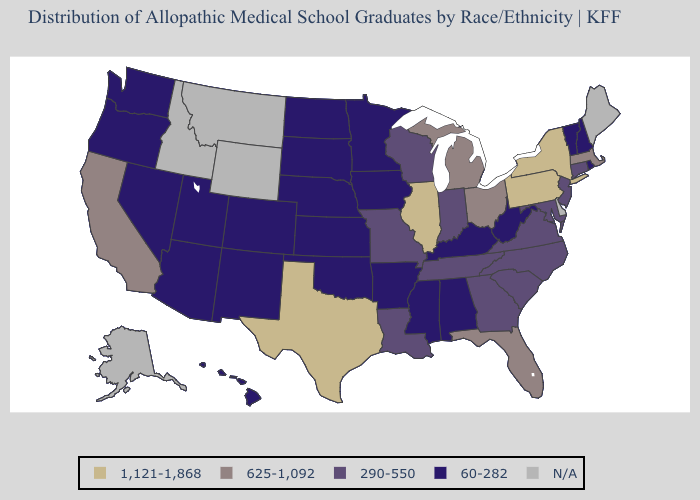What is the value of Florida?
Write a very short answer. 625-1,092. Name the states that have a value in the range 1,121-1,868?
Be succinct. Illinois, New York, Pennsylvania, Texas. What is the value of South Carolina?
Be succinct. 290-550. Among the states that border Georgia , does Alabama have the lowest value?
Keep it brief. Yes. What is the value of Missouri?
Be succinct. 290-550. What is the highest value in the USA?
Quick response, please. 1,121-1,868. Does Illinois have the highest value in the USA?
Answer briefly. Yes. What is the value of Florida?
Be succinct. 625-1,092. Name the states that have a value in the range 290-550?
Concise answer only. Connecticut, Georgia, Indiana, Louisiana, Maryland, Missouri, New Jersey, North Carolina, South Carolina, Tennessee, Virginia, Wisconsin. Name the states that have a value in the range 60-282?
Concise answer only. Alabama, Arizona, Arkansas, Colorado, Hawaii, Iowa, Kansas, Kentucky, Minnesota, Mississippi, Nebraska, Nevada, New Hampshire, New Mexico, North Dakota, Oklahoma, Oregon, Rhode Island, South Dakota, Utah, Vermont, Washington, West Virginia. What is the value of North Dakota?
Concise answer only. 60-282. What is the value of Massachusetts?
Quick response, please. 625-1,092. Which states have the highest value in the USA?
Short answer required. Illinois, New York, Pennsylvania, Texas. 